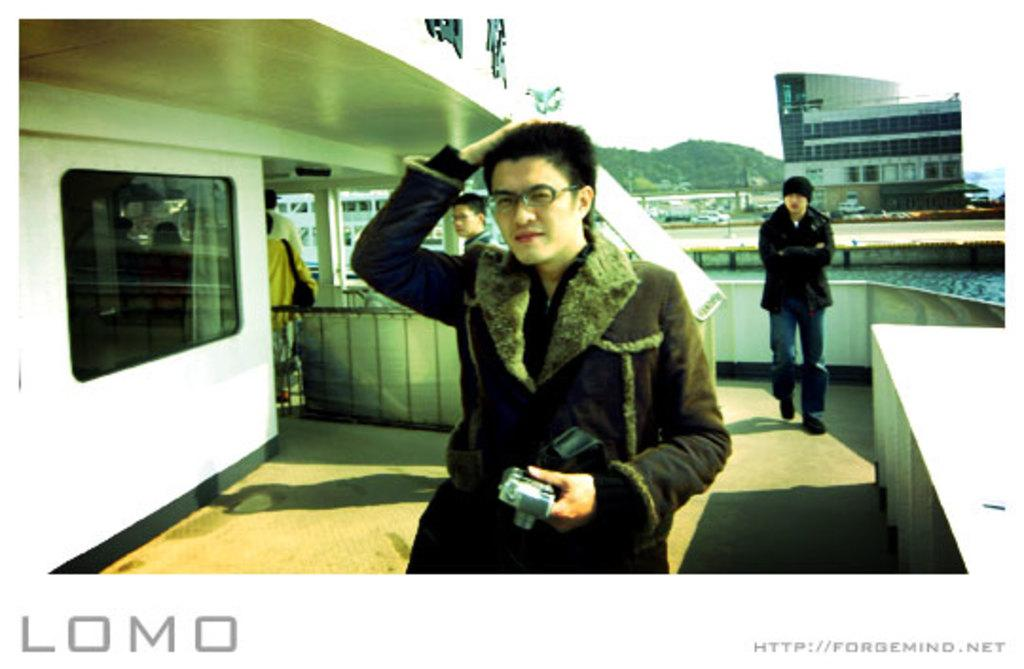Who is the main subject in the image? There is a man in the image. What is the man doing in the image? The man is walking. What is the man wearing in the image? The man is wearing a coat and spectacles. What can be seen on the right side of the image? There are buildings on the right side of the image. What type of pie is the man holding in the image? There is no pie present in the image; the man is wearing a coat and spectacles while walking. 